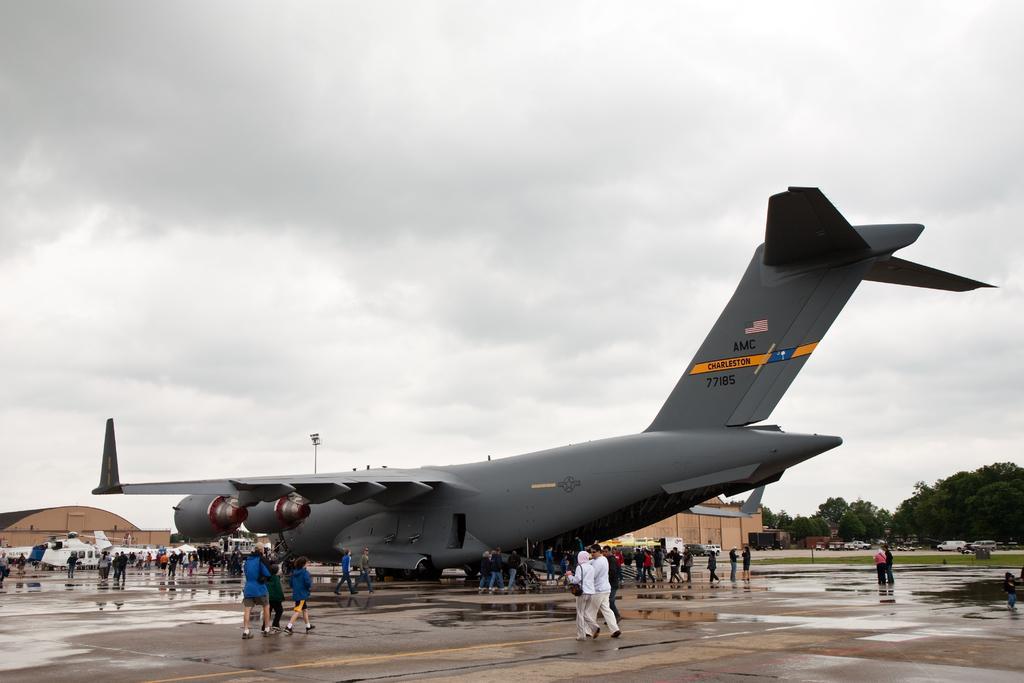Please provide a concise description of this image. In this picture we can see few planes and group of people, in the background we can find few buildings, vehicles, trees and clouds. 